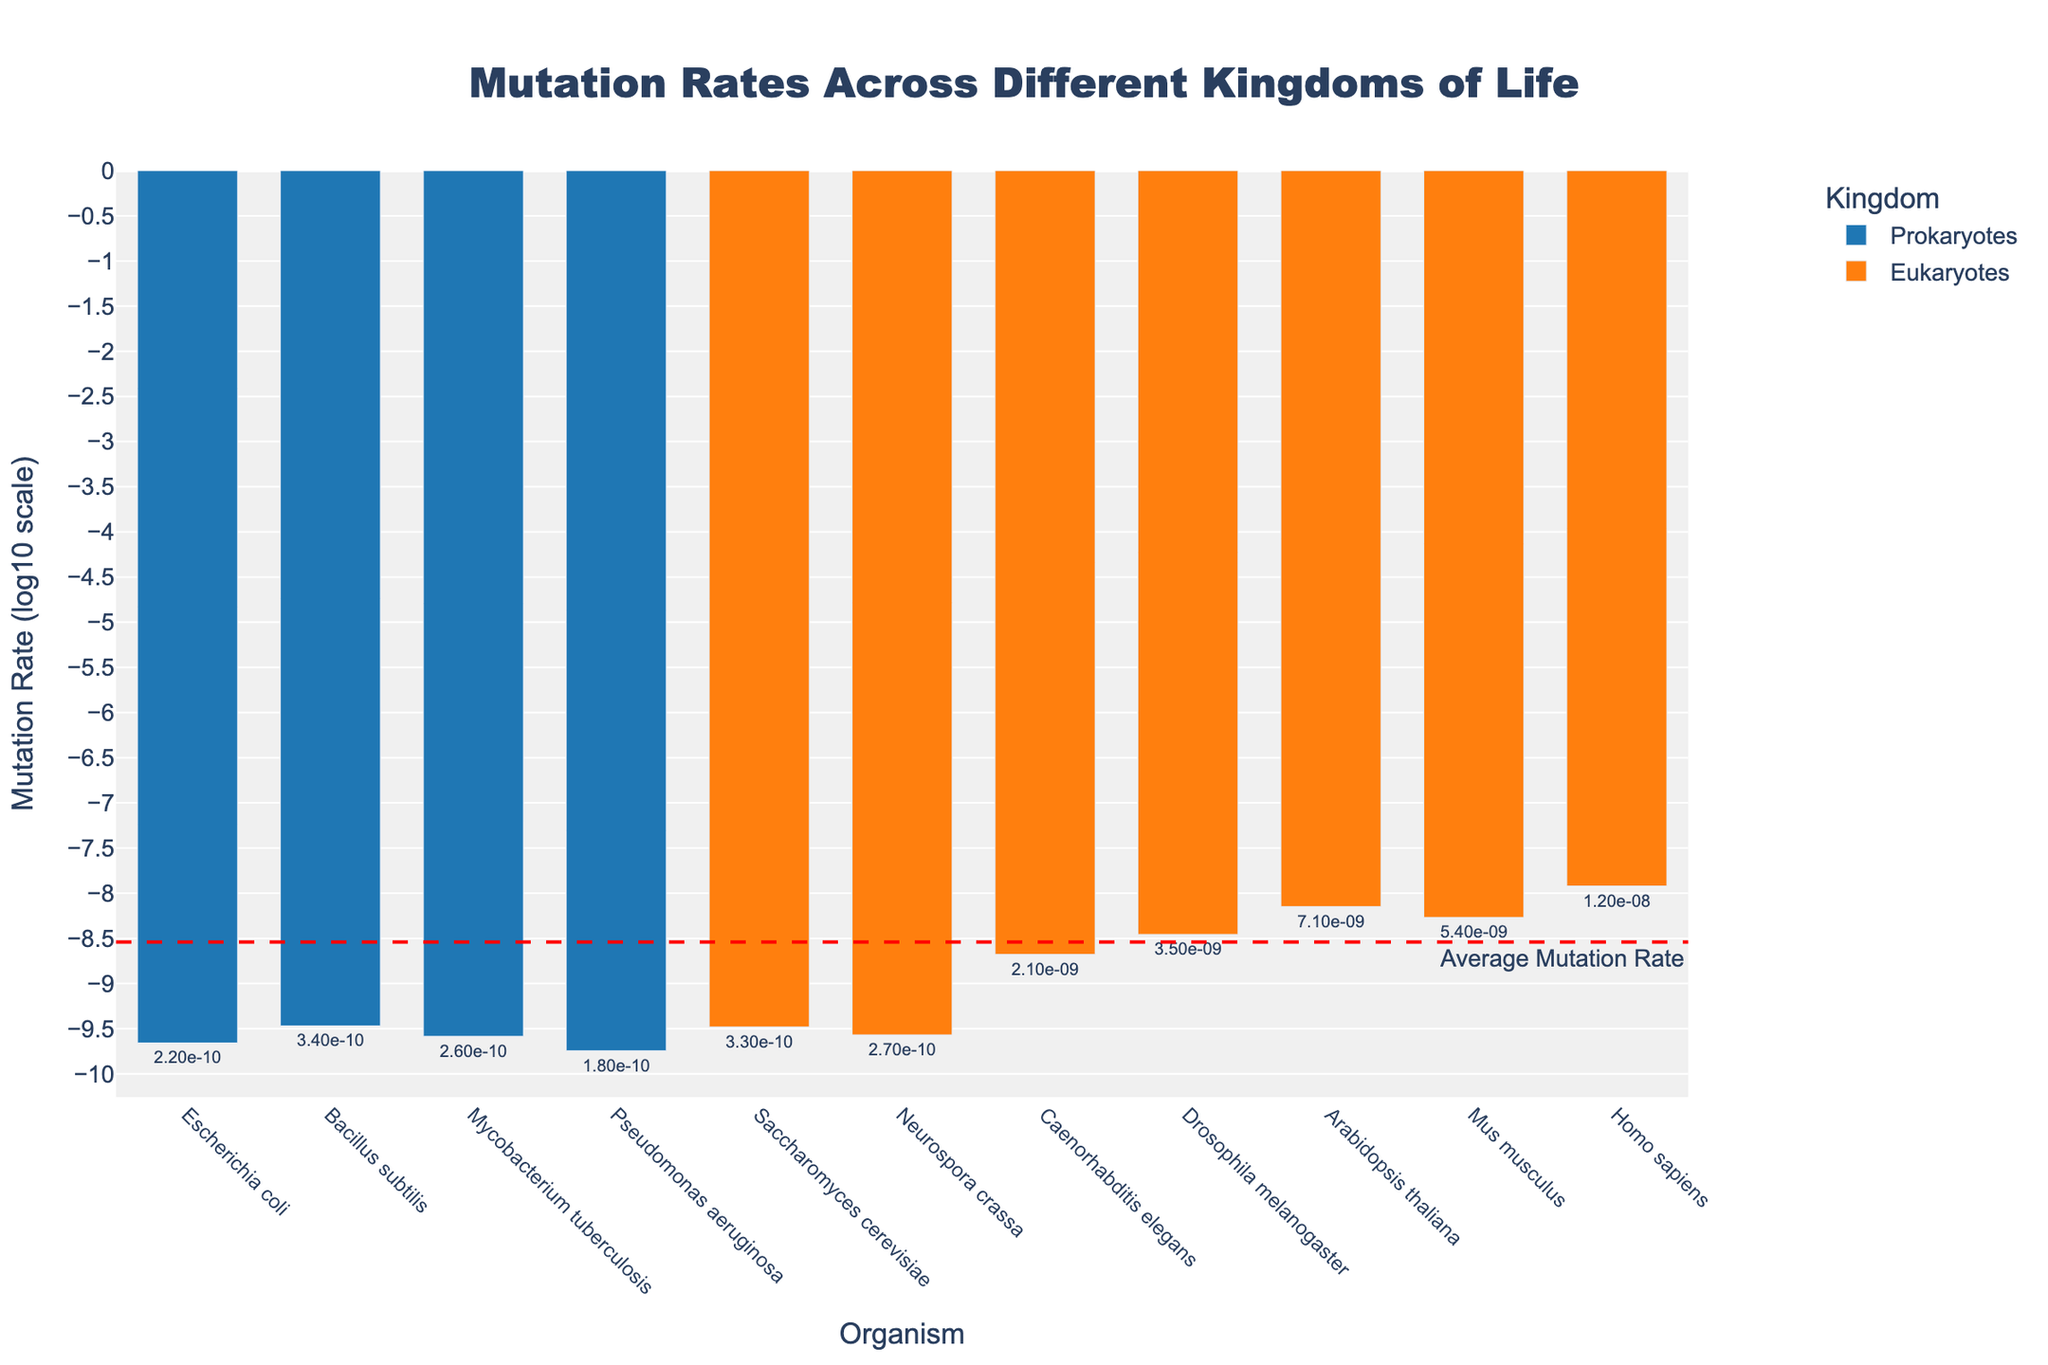What's the organism with the highest mutation rate? The highest mutation rate can be determined by looking at the tallest bar within the Eukaryotes category. Homo sapiens has the highest mutation rate in the chart.
Answer: Homo sapiens Which kingdom has the lower average mutation rate? To determine the lower average mutation rate, compare the average heights of the bars for Prokaryotes and Eukaryotes. Prokaryotes generally have shorter bars, indicating a lower average mutation rate.
Answer: Prokaryotes How many organisms in Eukaryotes have a mutation rate greater than Caenorhabditis elegans? Identify the bar height for Caenorhabditis elegans within Eukaryotes. Count how many bars are taller, which is Drosophila melanogaster, Arabidopsis thaliana, Mus musculus, and Homo sapiens.
Answer: 4 What is the rank of Bacillus subtilis in terms of mutation rate among Prokaryotes? Rank the Prokaryotes based on their bar heights. Escherichia coli (lowest), Pseudomonas aeruginosa, Mycobacterium tuberculosis, Bacillus subtilis (highest).
Answer: 1st Is the mutation rate of Saccharomyces cerevisiae greater or less than Bacillus subtilis? Compare the height of the bars for Saccharomyces cerevisiae (Eukaryotes) and Bacillus subtilis (Prokaryotes). Saccharomyces cerevisiae is slightly less.
Answer: Less On average, are Eukaryotes' mutation rates above or below the overall average mutation rate annotated on the chart? Identify if the majority of Eukaryotes' bars are above or below the red average mutation rate line. Most Eukaryotes' bars appear above the red line.
Answer: Above Which Prokaryote has the lowest mutation rate? Look for the shortest bar among the Prokaryotes. The shortest is Pseudomonas aeruginosa.
Answer: Pseudomonas aeruginosa What's the difference in mutation rate (log10 scale) between the highest and lowest Eukaryotes? Measure the height difference between the tallest (Homo sapiens) and the shortest (Saccharomyces cerevisiae) bars among Eukaryotes. Approximate difference is about 4.52 log10 units.
Answer: ~4.52 log10 units 